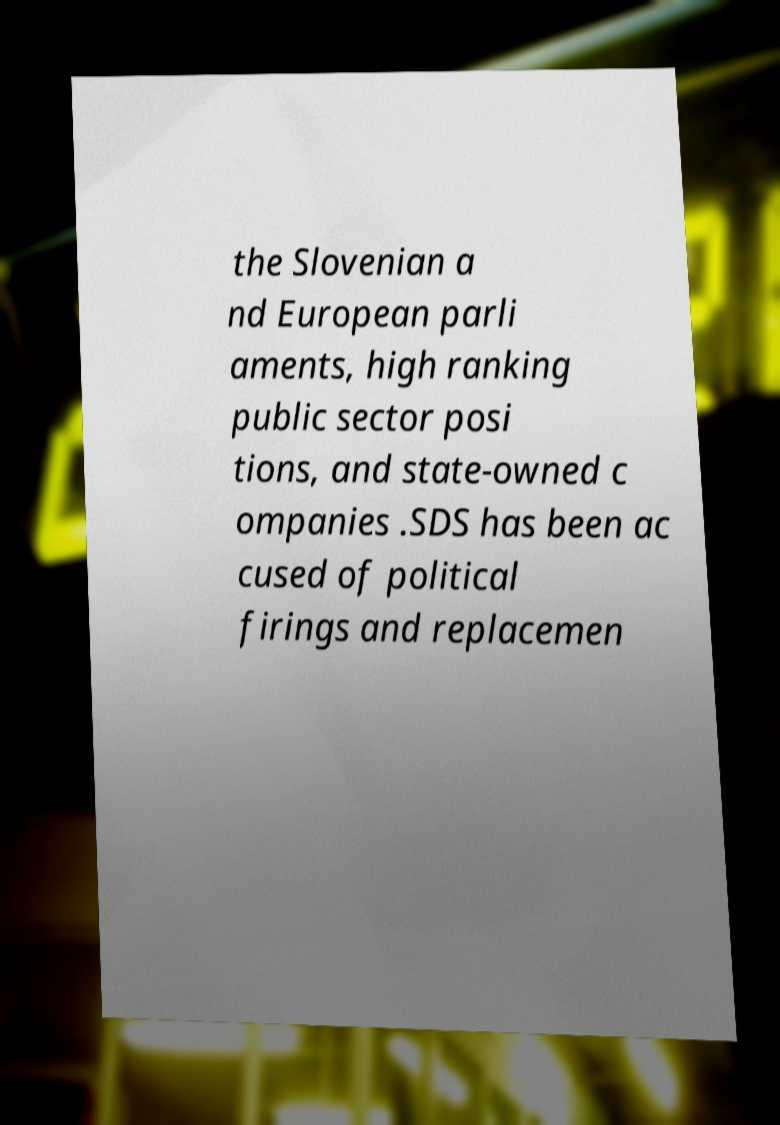Could you extract and type out the text from this image? the Slovenian a nd European parli aments, high ranking public sector posi tions, and state-owned c ompanies .SDS has been ac cused of political firings and replacemen 